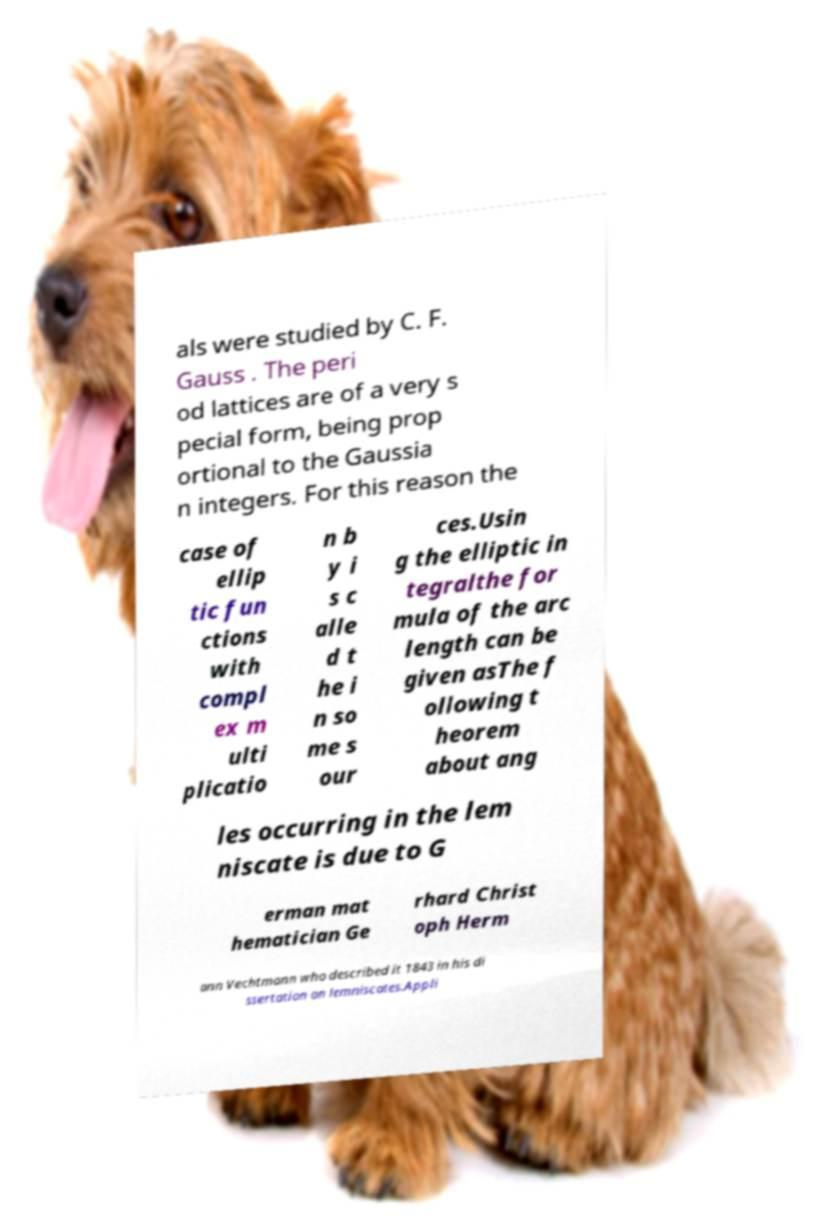For documentation purposes, I need the text within this image transcribed. Could you provide that? als were studied by C. F. Gauss . The peri od lattices are of a very s pecial form, being prop ortional to the Gaussia n integers. For this reason the case of ellip tic fun ctions with compl ex m ulti plicatio n b y i s c alle d t he i n so me s our ces.Usin g the elliptic in tegralthe for mula of the arc length can be given asThe f ollowing t heorem about ang les occurring in the lem niscate is due to G erman mat hematician Ge rhard Christ oph Herm ann Vechtmann who described it 1843 in his di ssertation on lemniscates.Appli 